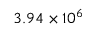Convert formula to latex. <formula><loc_0><loc_0><loc_500><loc_500>3 . 9 4 \times 1 0 ^ { 6 }</formula> 